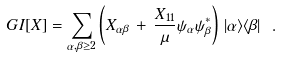Convert formula to latex. <formula><loc_0><loc_0><loc_500><loc_500>\ G I [ X ] = \sum _ { \alpha , \beta \geq 2 } \left ( X _ { \alpha \beta } \, + \, \frac { X _ { 1 1 } } { \mu } \psi _ { \alpha } \psi ^ { * } _ { \beta } \right ) \, | \alpha \rangle \langle \beta | \ .</formula> 